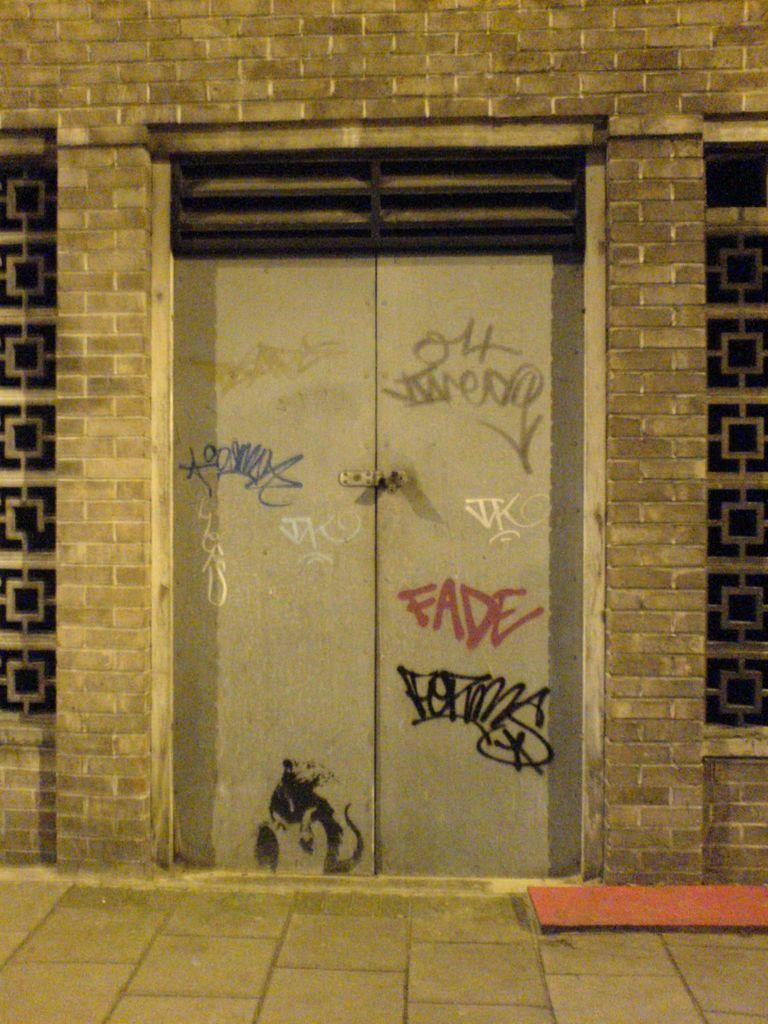What type of openings can be seen in the image? There are windows in the image. What other architectural feature is present in the image? There is a door in the image. To which structure does the door belong? The door belongs to a building. Is there any writing or symbols on the door? Yes, there is some text on the door. How does the doll increase the value of the building in the image? There is no doll present in the image, so it cannot increase the value of the building. 